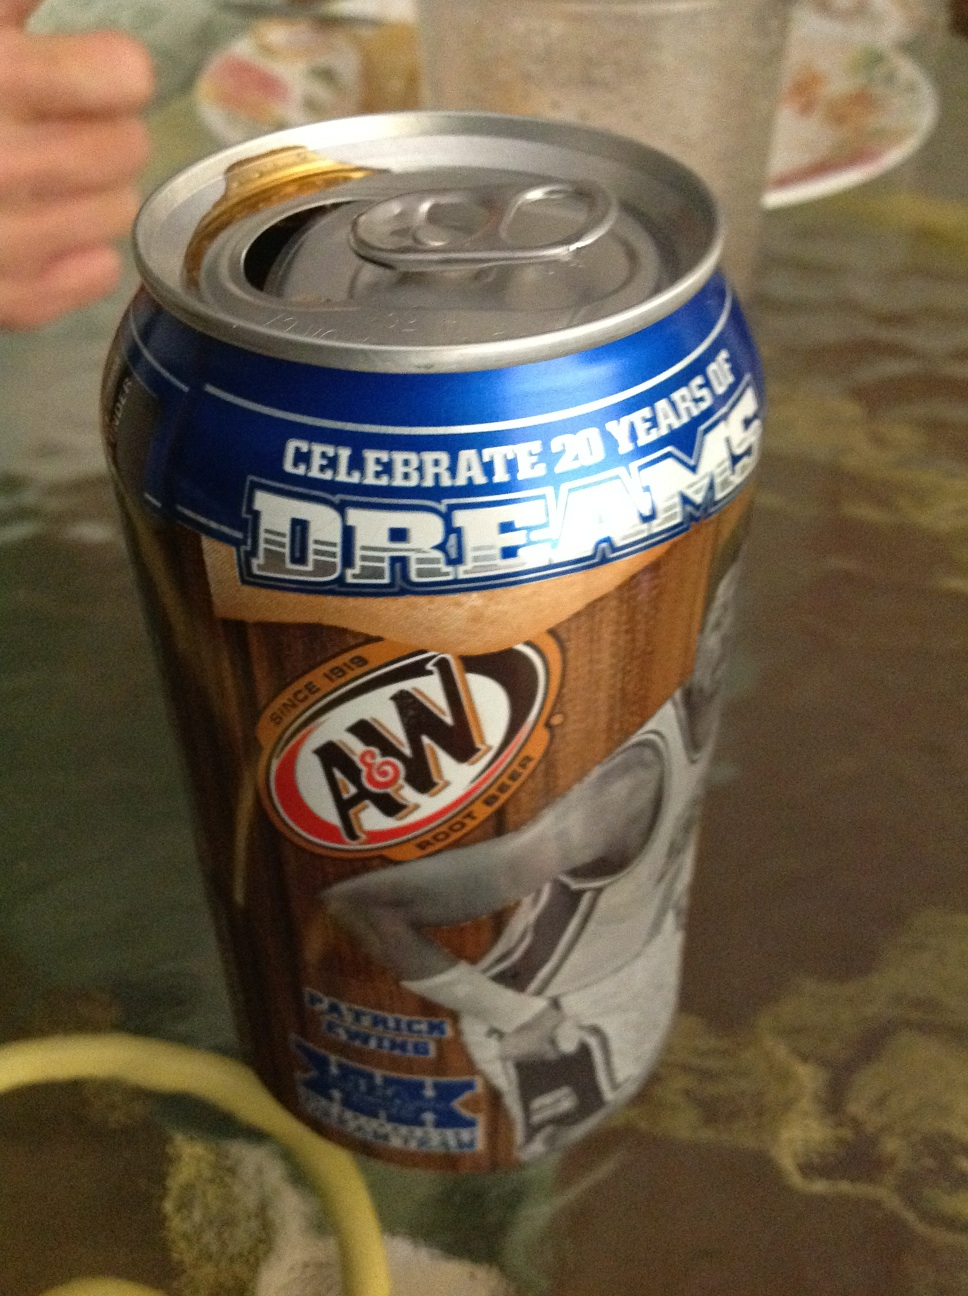Describe the design of this can. The can has a striking design with a blue and gold color scheme. It prominently features the A&W logo along with text that reads 'Celebrate 20 years of dreams'. The can also includes an image of a basketball player in action, adding a dynamic and sporty feel to the design. 